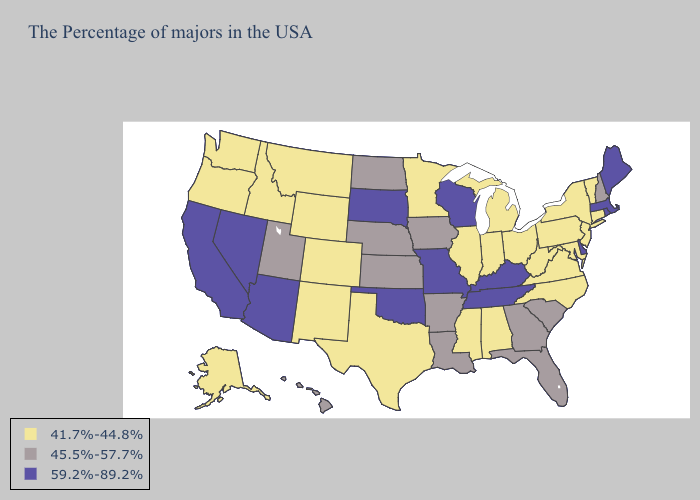What is the lowest value in the MidWest?
Concise answer only. 41.7%-44.8%. Does Colorado have the lowest value in the USA?
Answer briefly. Yes. What is the value of Idaho?
Be succinct. 41.7%-44.8%. What is the highest value in the West ?
Give a very brief answer. 59.2%-89.2%. Does New Jersey have the highest value in the USA?
Give a very brief answer. No. What is the lowest value in states that border Minnesota?
Quick response, please. 45.5%-57.7%. What is the value of New Mexico?
Quick response, please. 41.7%-44.8%. What is the highest value in the USA?
Answer briefly. 59.2%-89.2%. Among the states that border West Virginia , does Pennsylvania have the lowest value?
Be succinct. Yes. What is the value of Indiana?
Write a very short answer. 41.7%-44.8%. Which states have the lowest value in the MidWest?
Concise answer only. Ohio, Michigan, Indiana, Illinois, Minnesota. Does Vermont have the same value as Maine?
Write a very short answer. No. Name the states that have a value in the range 59.2%-89.2%?
Short answer required. Maine, Massachusetts, Rhode Island, Delaware, Kentucky, Tennessee, Wisconsin, Missouri, Oklahoma, South Dakota, Arizona, Nevada, California. Name the states that have a value in the range 41.7%-44.8%?
Short answer required. Vermont, Connecticut, New York, New Jersey, Maryland, Pennsylvania, Virginia, North Carolina, West Virginia, Ohio, Michigan, Indiana, Alabama, Illinois, Mississippi, Minnesota, Texas, Wyoming, Colorado, New Mexico, Montana, Idaho, Washington, Oregon, Alaska. What is the value of Utah?
Be succinct. 45.5%-57.7%. 